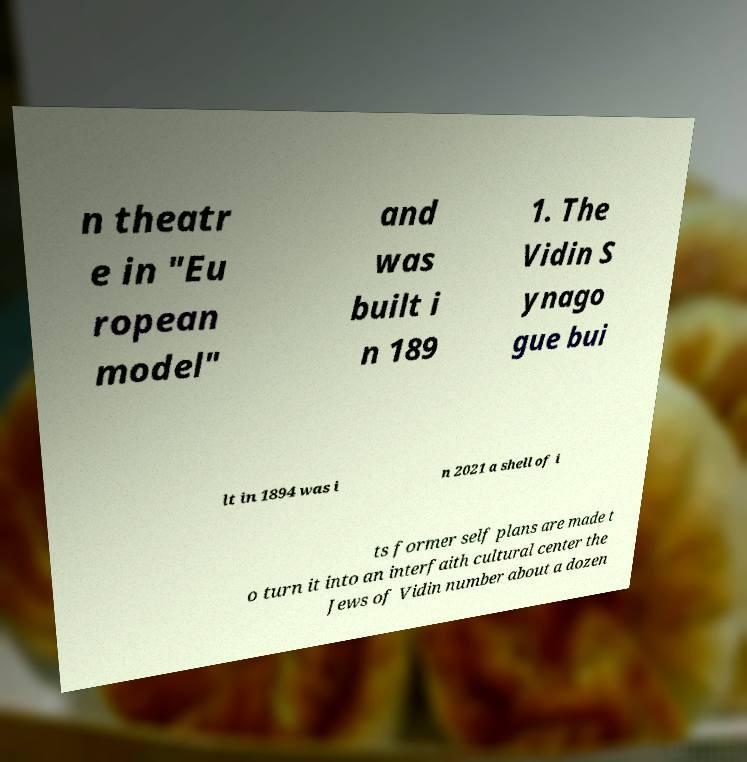Can you accurately transcribe the text from the provided image for me? n theatr e in "Eu ropean model" and was built i n 189 1. The Vidin S ynago gue bui lt in 1894 was i n 2021 a shell of i ts former self plans are made t o turn it into an interfaith cultural center the Jews of Vidin number about a dozen 